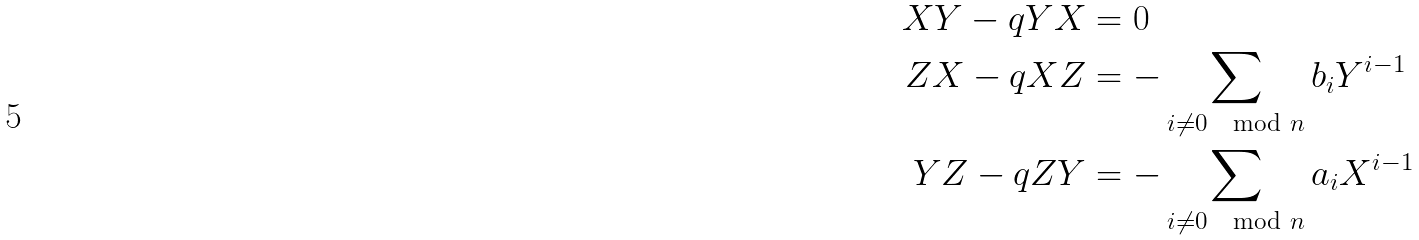<formula> <loc_0><loc_0><loc_500><loc_500>X Y - q Y X & = 0 \\ Z X - q X Z & = - \sum _ { i \neq 0 \mod n } b _ { i } Y ^ { i - 1 } \\ Y Z - q Z Y & = - \sum _ { i \neq 0 \mod n } a _ { i } X ^ { i - 1 }</formula> 